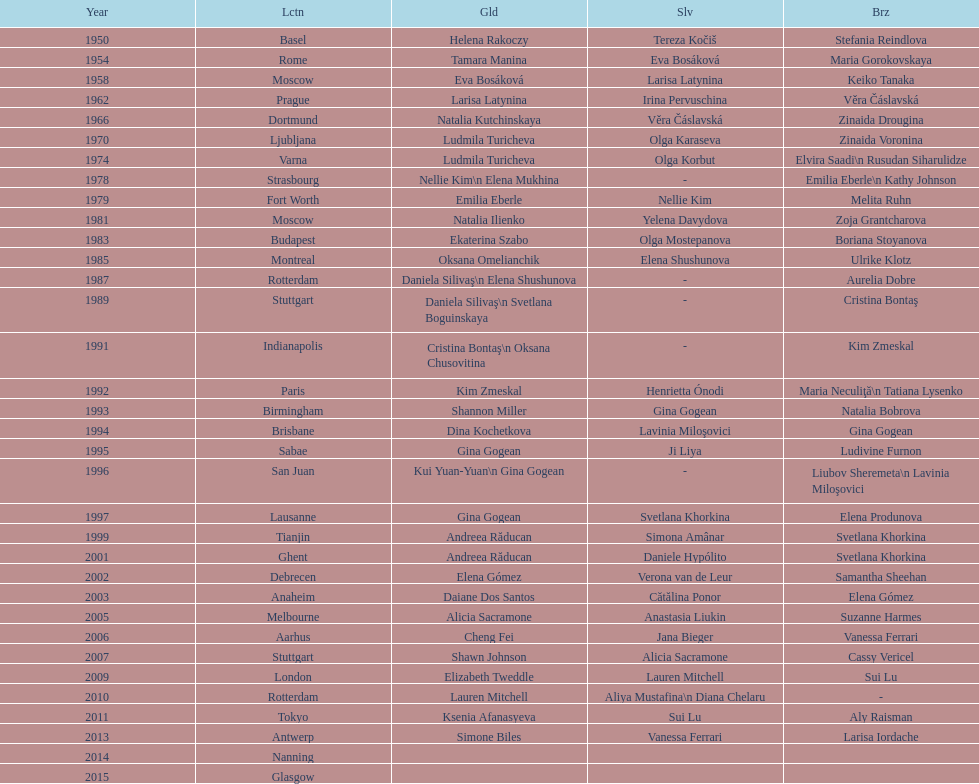Which two american rivals won consecutive floor exercise gold medals at the artistic gymnastics world championships in 1992 and 1993? Kim Zmeskal, Shannon Miller. 